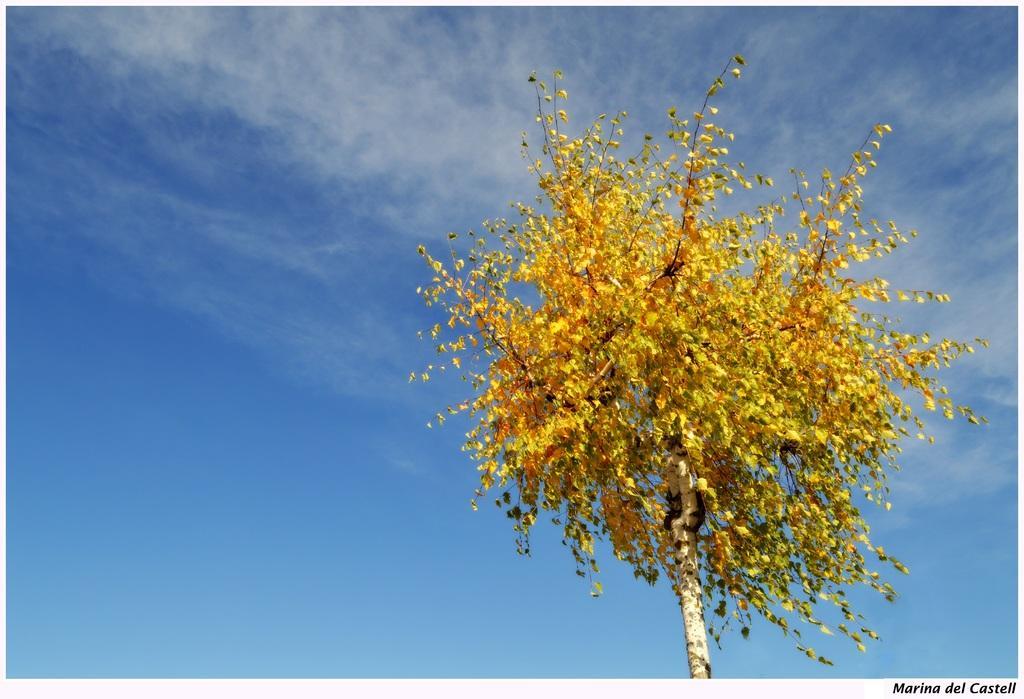Can you describe this image briefly? In this picture, we see a tree. It is in yellow color. In the background, we see the sky, which is blue in color. 